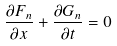<formula> <loc_0><loc_0><loc_500><loc_500>\frac { \partial F _ { n } } { \partial x } + \frac { \partial G _ { n } } { \partial t } = 0</formula> 